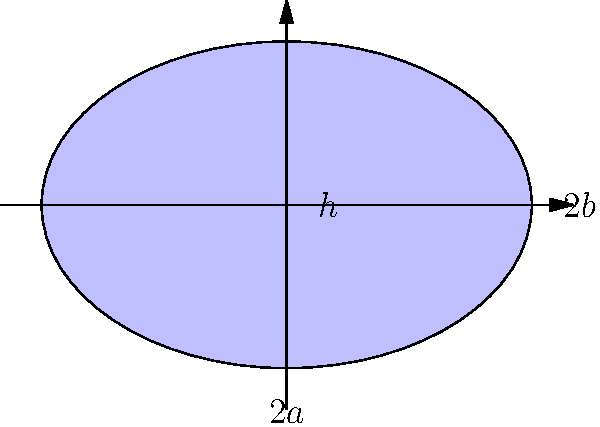An ancient reservoir has been discovered with an elliptical shape. The major axis (2a) of the ellipse measures 120 meters, and the minor axis (2b) measures 80 meters. If the maximum depth (h) of the reservoir is 10 meters, estimate its storage capacity in cubic meters. Assume the reservoir has the shape of half an ellipsoid. To estimate the storage capacity of the ancient reservoir, we'll follow these steps:

1) The volume of half an ellipsoid is given by the formula:

   $$V = \frac{2}{3}\pi a b h$$

   Where:
   $a$ = semi-major axis
   $b$ = semi-minor axis
   $h$ = depth

2) From the given information:
   $2a = 120$ m, so $a = 60$ m
   $2b = 80$ m, so $b = 40$ m
   $h = 10$ m

3) Substituting these values into the formula:

   $$V = \frac{2}{3}\pi (60)(40)(10)$$

4) Simplify:
   $$V = \frac{2}{3}\pi (24000)$$
   $$V = 16000\pi$$

5) Calculate the final value:
   $$V \approx 50265.5 \text{ m}^3$$

Therefore, the estimated storage capacity of the ancient reservoir is approximately 50,266 cubic meters.
Answer: 50,266 cubic meters 